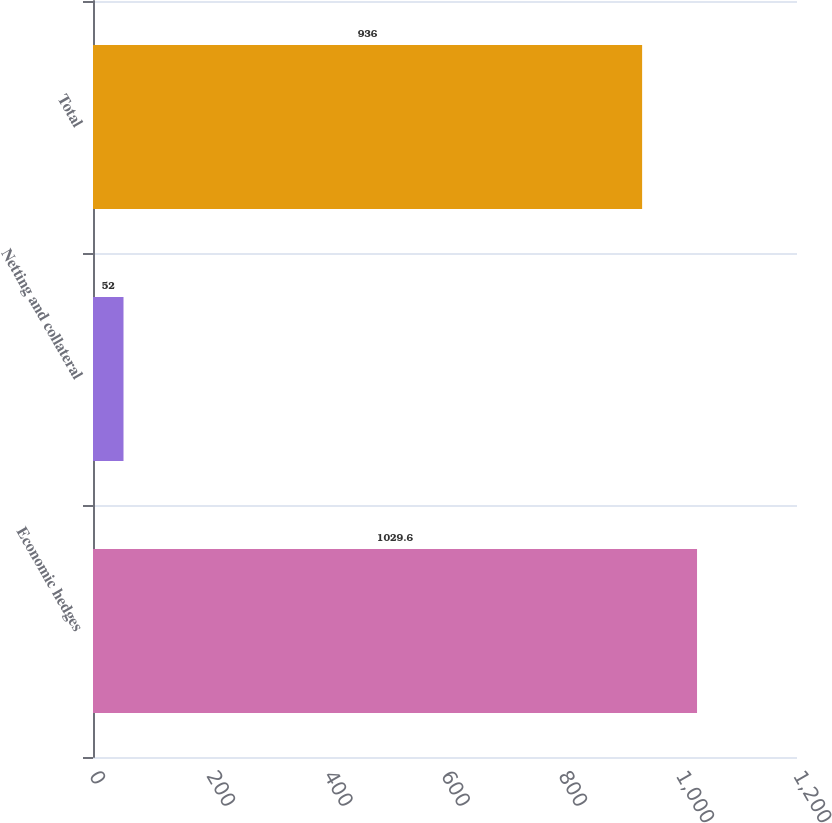Convert chart. <chart><loc_0><loc_0><loc_500><loc_500><bar_chart><fcel>Economic hedges<fcel>Netting and collateral<fcel>Total<nl><fcel>1029.6<fcel>52<fcel>936<nl></chart> 